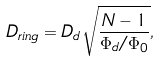<formula> <loc_0><loc_0><loc_500><loc_500>D _ { r i n g } = D _ { d } \sqrt { \frac { N - 1 } { \Phi _ { d } / \Phi _ { 0 } } } ,</formula> 